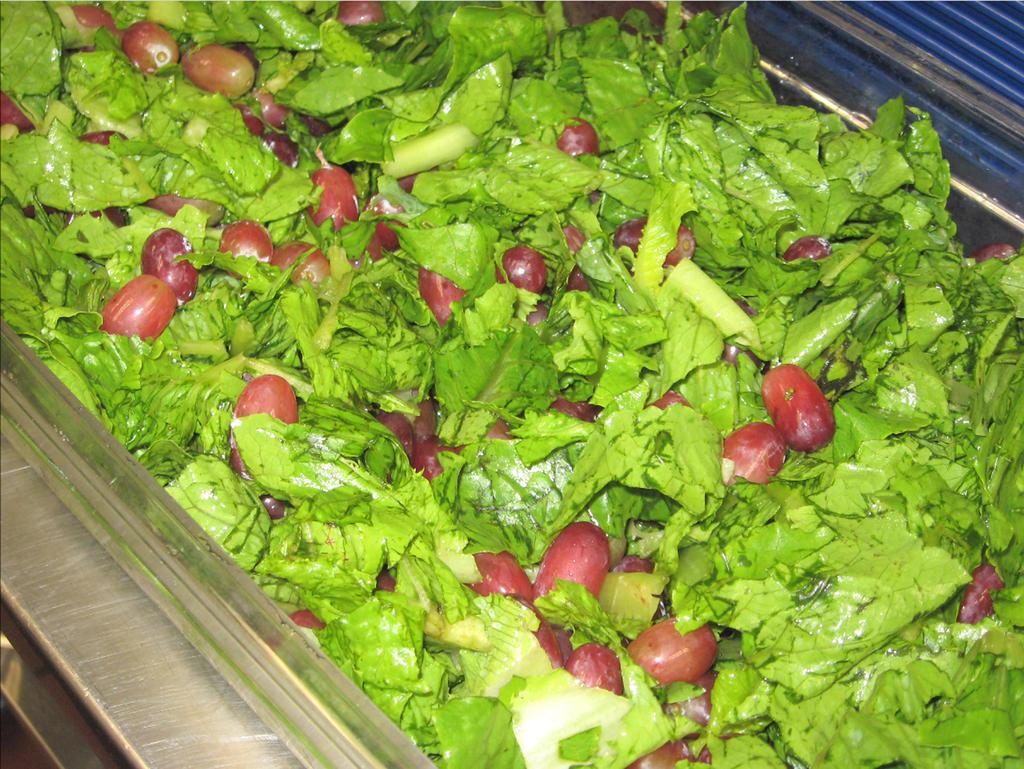What type of food is in the center of the image? There are vegetables in the center of the image. What type of chicken can be seen in the image? There is no chicken present in the image; it features vegetables in the center. What type of wax is visible in the image? There is no wax present in the image. What type of vest is worn by the vegetables in the image? The vegetables in the image are not wearing any vest, as they are inanimate objects. 